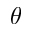<formula> <loc_0><loc_0><loc_500><loc_500>\theta</formula> 